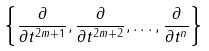Convert formula to latex. <formula><loc_0><loc_0><loc_500><loc_500>\left \{ \frac { \partial } { \partial t ^ { 2 m + 1 } } , \frac { \partial } { \partial t ^ { 2 m + 2 } } , \dots , \frac { \partial } { \partial t ^ { n } } \right \}</formula> 